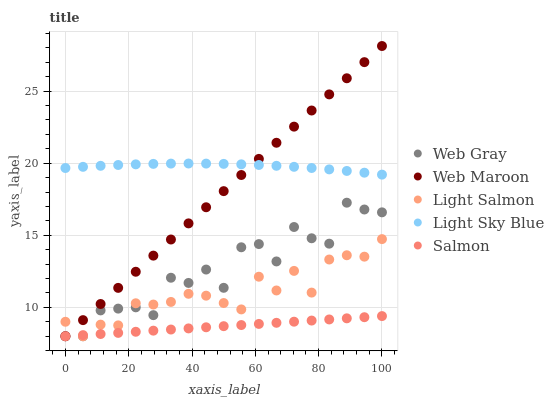Does Salmon have the minimum area under the curve?
Answer yes or no. Yes. Does Light Sky Blue have the maximum area under the curve?
Answer yes or no. Yes. Does Light Salmon have the minimum area under the curve?
Answer yes or no. No. Does Light Salmon have the maximum area under the curve?
Answer yes or no. No. Is Salmon the smoothest?
Answer yes or no. Yes. Is Web Gray the roughest?
Answer yes or no. Yes. Is Light Salmon the smoothest?
Answer yes or no. No. Is Light Salmon the roughest?
Answer yes or no. No. Does Salmon have the lowest value?
Answer yes or no. Yes. Does Light Sky Blue have the lowest value?
Answer yes or no. No. Does Web Maroon have the highest value?
Answer yes or no. Yes. Does Light Salmon have the highest value?
Answer yes or no. No. Is Web Gray less than Light Sky Blue?
Answer yes or no. Yes. Is Light Sky Blue greater than Salmon?
Answer yes or no. Yes. Does Light Salmon intersect Salmon?
Answer yes or no. Yes. Is Light Salmon less than Salmon?
Answer yes or no. No. Is Light Salmon greater than Salmon?
Answer yes or no. No. Does Web Gray intersect Light Sky Blue?
Answer yes or no. No. 